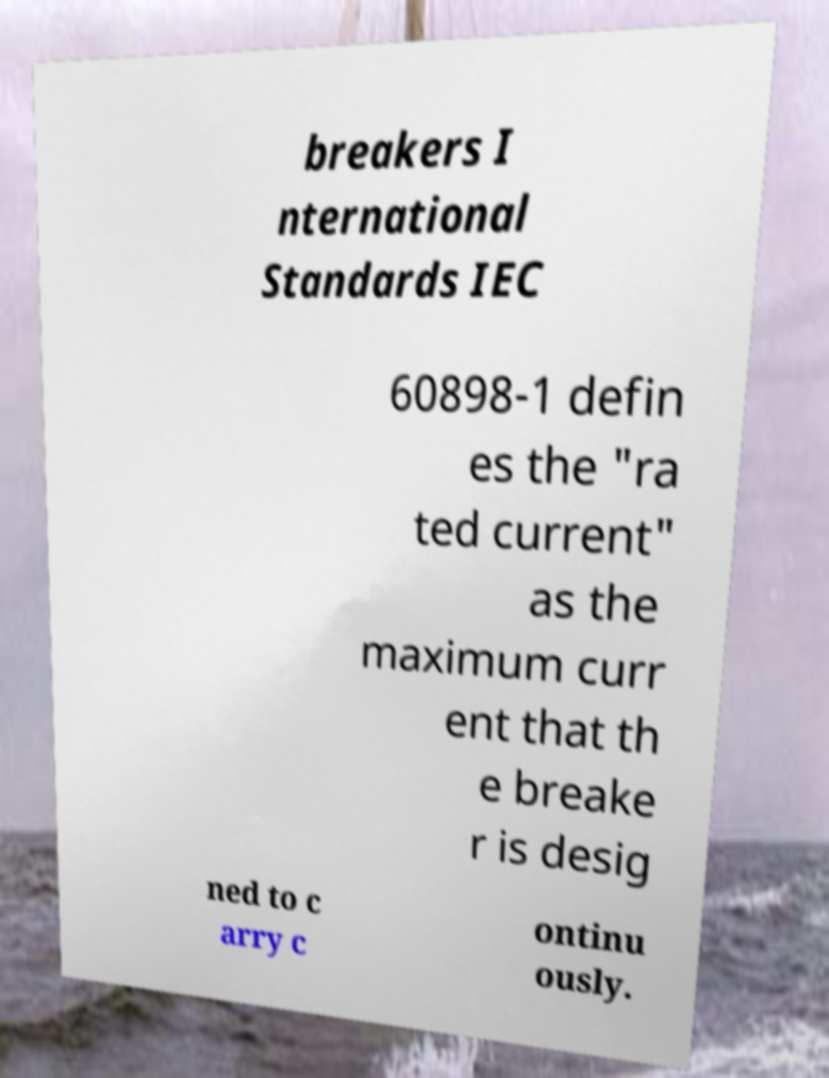There's text embedded in this image that I need extracted. Can you transcribe it verbatim? breakers I nternational Standards IEC 60898-1 defin es the "ra ted current" as the maximum curr ent that th e breake r is desig ned to c arry c ontinu ously. 